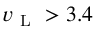Convert formula to latex. <formula><loc_0><loc_0><loc_500><loc_500>v _ { L } > 3 . 4</formula> 